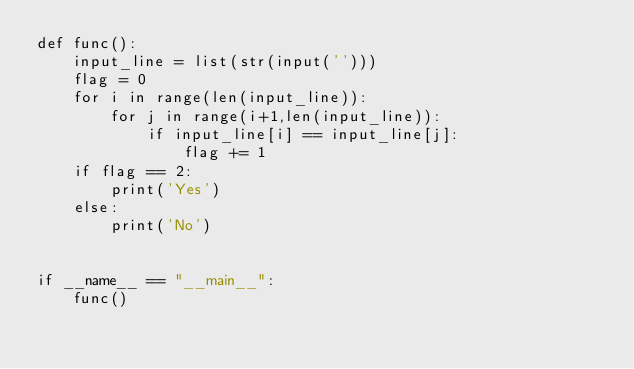<code> <loc_0><loc_0><loc_500><loc_500><_Python_>def func():
    input_line = list(str(input('')))
    flag = 0
    for i in range(len(input_line)):
        for j in range(i+1,len(input_line)):
            if input_line[i] == input_line[j]:
                flag += 1
    if flag == 2:
        print('Yes')
    else:
        print('No')


if __name__ == "__main__":
    func()
                </code> 